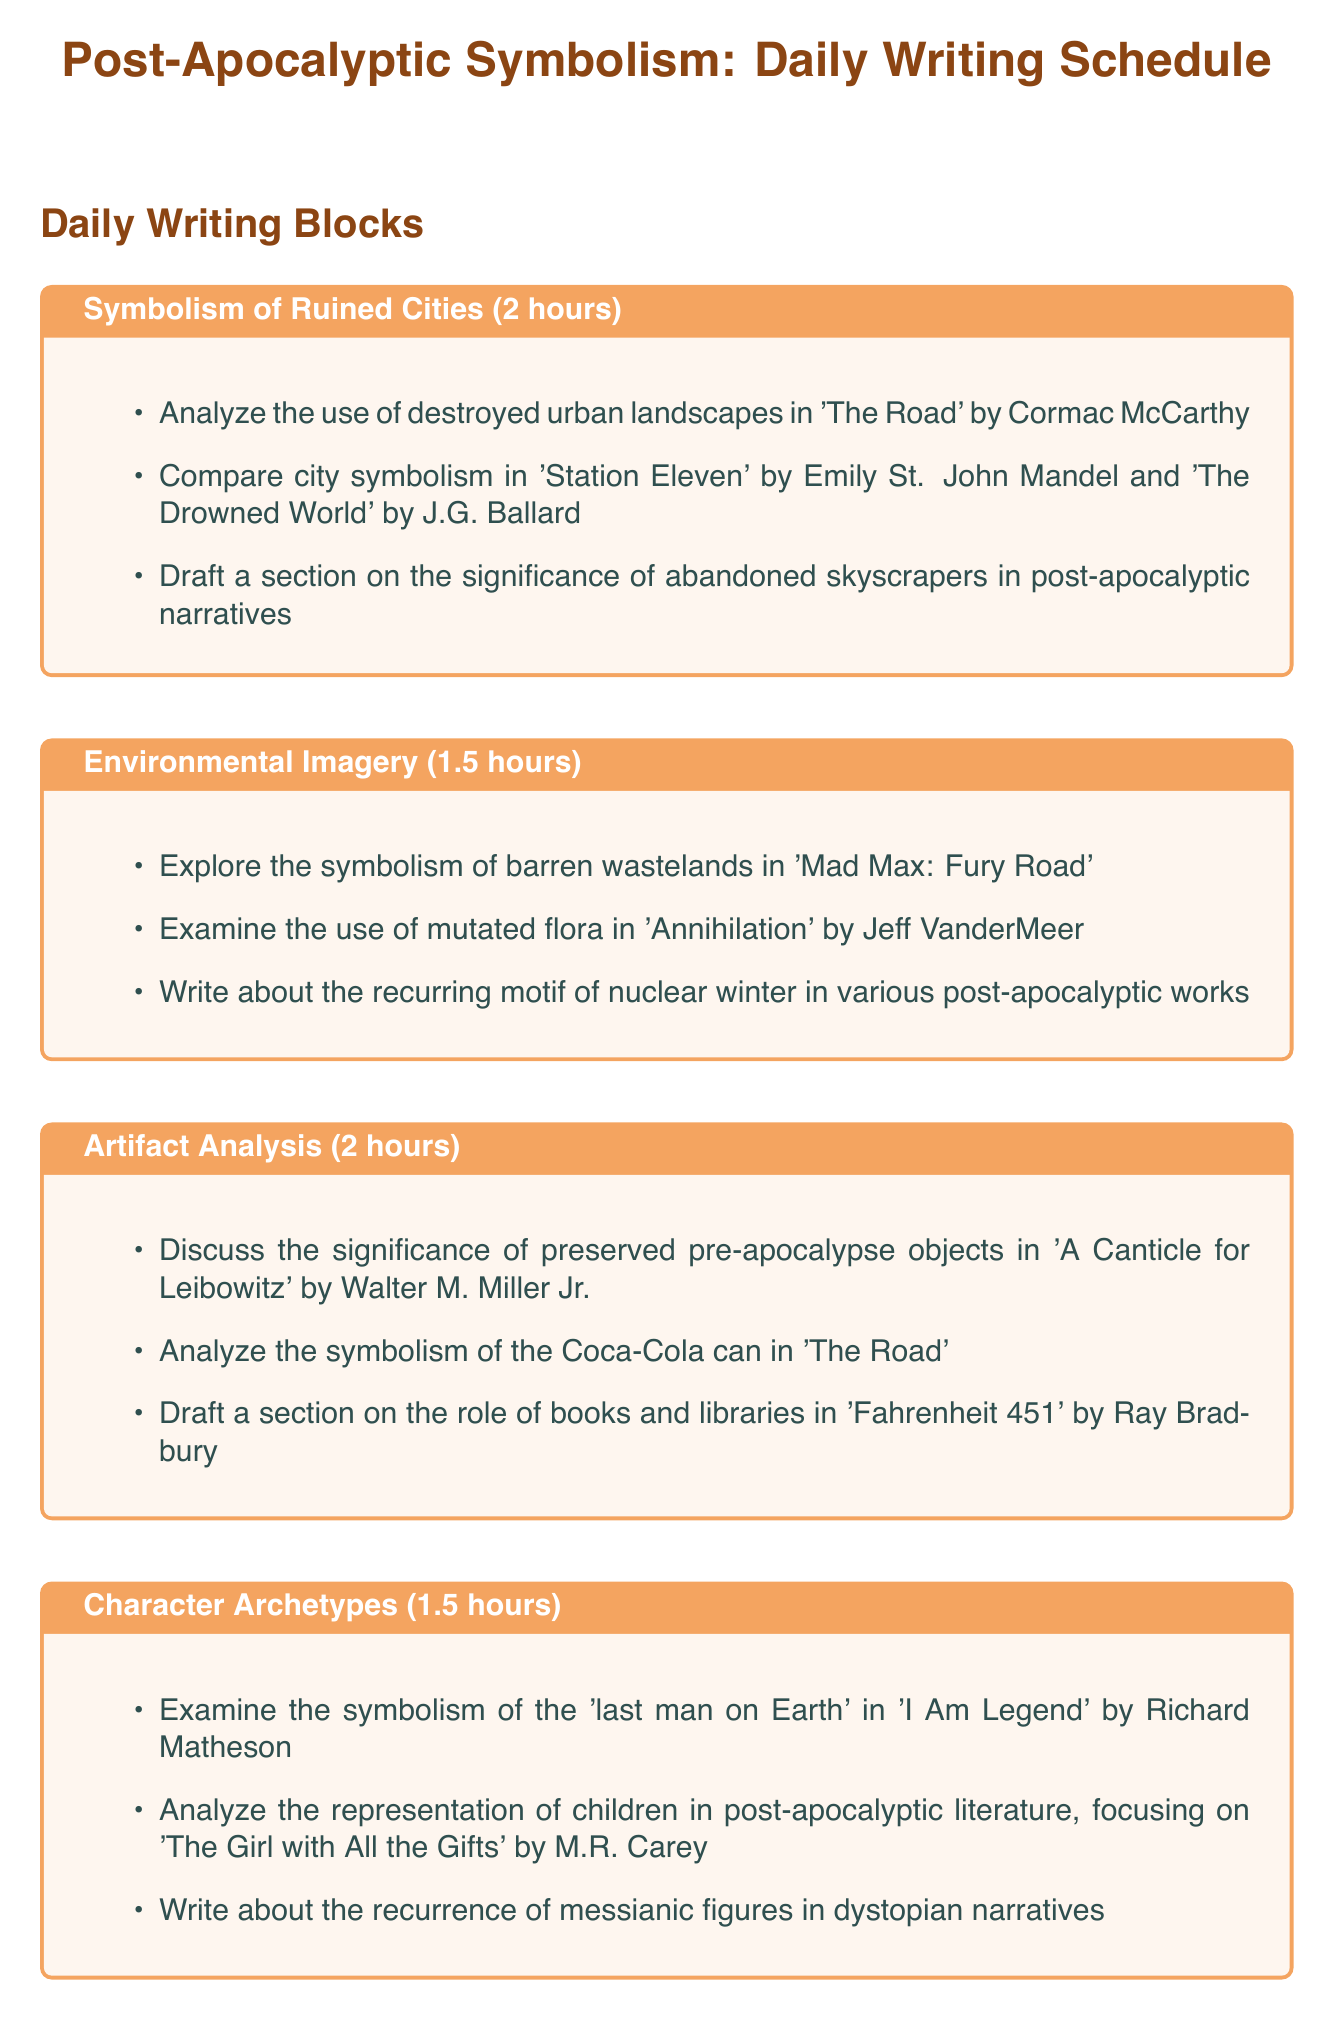What is the duration of the "Symbolism of Ruined Cities" block? The duration is specified at the start of the block, which is 2 hours.
Answer: 2 hours How many tasks are listed under "Environmental Imagery"? The number of tasks can be counted directly in the block, which lists three tasks.
Answer: 3 Which author is associated with "The Hunger Games"? The author is mentioned under the relevant task, identified as Suzanne Collins.
Answer: Suzanne Collins What is the main focus of the "Character Archetypes" block? The main focus is indicated by the tasks listed, which center on various character representations in post-apocalyptic literature.
Answer: Character representations How long is the "Artifact Analysis" writing block? The length of the block is given at the beginning, which is 2 hours.
Answer: 2 hours What type of societies are discussed in the "New Social Orders" block? The type of societies referenced are emerging tribal societies, as indicated in the tasks.
Answer: Tribal societies Who wrote "The Handmaid's Tale"? The author of the work is mentioned in the task, identified as Margaret Atwood.
Answer: Margaret Atwood Which post-apocalyptic work mentions mutated flora? The task refers to "Annihilation" by Jeff VanderMeer as the discussed work.
Answer: Annihilation What is the total duration of the daily writing schedule blocks? The total is calculated by adding the individual durations of all blocks, which equals 11.5 hours.
Answer: 11.5 hours 